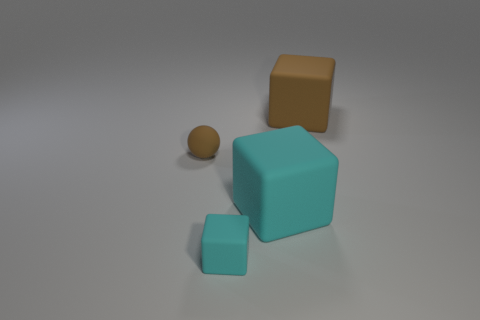There is a big cube that is the same color as the small ball; what is its material?
Provide a short and direct response. Rubber. What is the color of the other large thing that is the same material as the big cyan object?
Keep it short and to the point. Brown. There is a brown matte thing that is in front of the cube that is behind the big thing that is in front of the big brown matte cube; how big is it?
Your answer should be compact. Small. Is the number of matte blocks less than the number of big purple cylinders?
Provide a succinct answer. No. What is the color of the small object that is the same shape as the big cyan thing?
Your response must be concise. Cyan. Are there any brown things that are in front of the brown matte object that is in front of the brown object that is right of the big cyan thing?
Provide a succinct answer. No. Is the shape of the large cyan rubber thing the same as the tiny brown object?
Offer a terse response. No. Are there fewer small matte things right of the small brown rubber thing than big cyan blocks?
Your response must be concise. No. There is a large block right of the large cube that is left of the brown thing that is behind the tiny brown sphere; what color is it?
Provide a succinct answer. Brown. What number of rubber things are either brown cubes or large cyan cubes?
Ensure brevity in your answer.  2. 